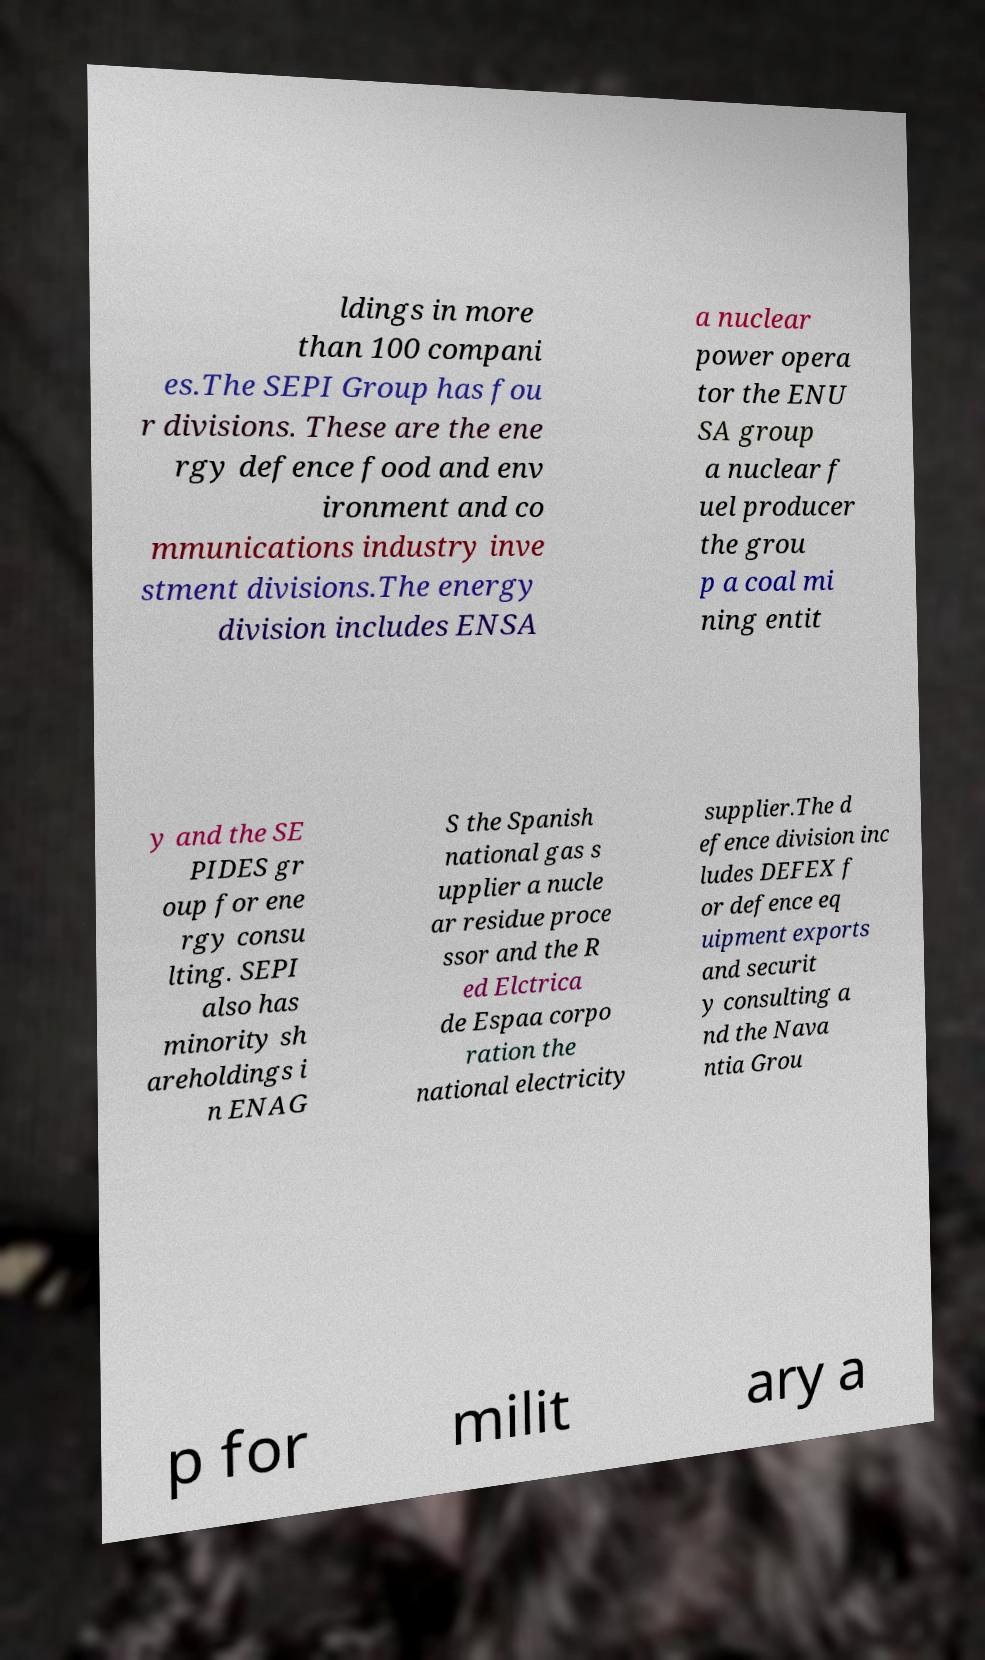I need the written content from this picture converted into text. Can you do that? ldings in more than 100 compani es.The SEPI Group has fou r divisions. These are the ene rgy defence food and env ironment and co mmunications industry inve stment divisions.The energy division includes ENSA a nuclear power opera tor the ENU SA group a nuclear f uel producer the grou p a coal mi ning entit y and the SE PIDES gr oup for ene rgy consu lting. SEPI also has minority sh areholdings i n ENAG S the Spanish national gas s upplier a nucle ar residue proce ssor and the R ed Elctrica de Espaa corpo ration the national electricity supplier.The d efence division inc ludes DEFEX f or defence eq uipment exports and securit y consulting a nd the Nava ntia Grou p for milit ary a 